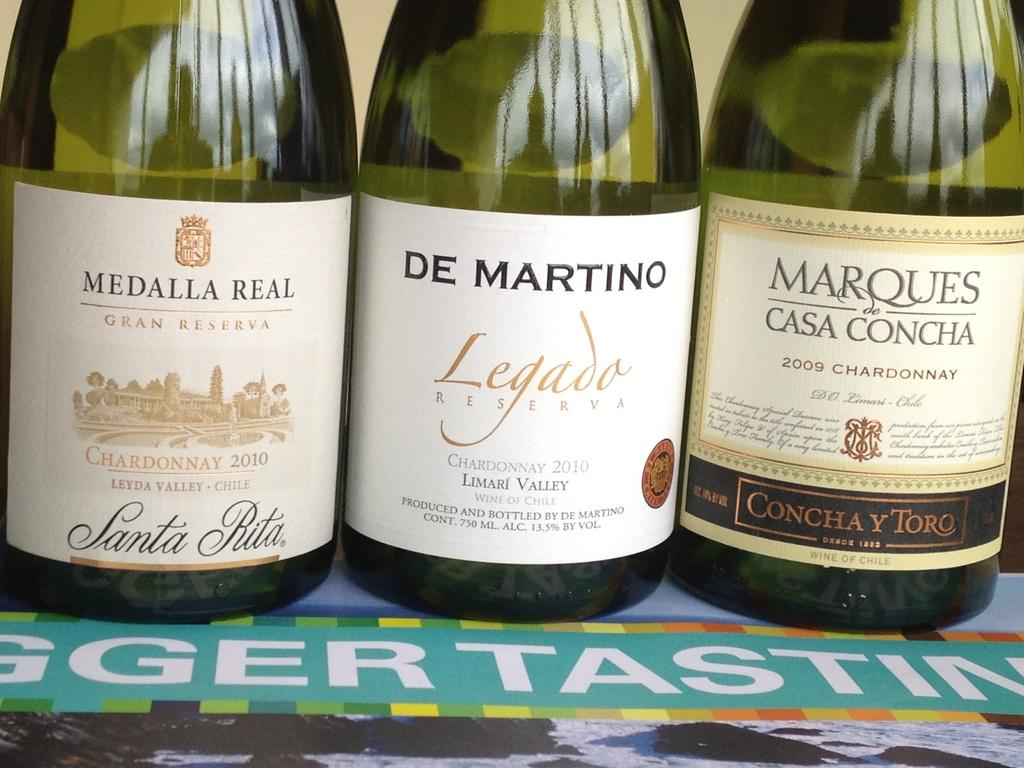<image>
Present a compact description of the photo's key features. Bottles of alcohol with a label that says Legada. 